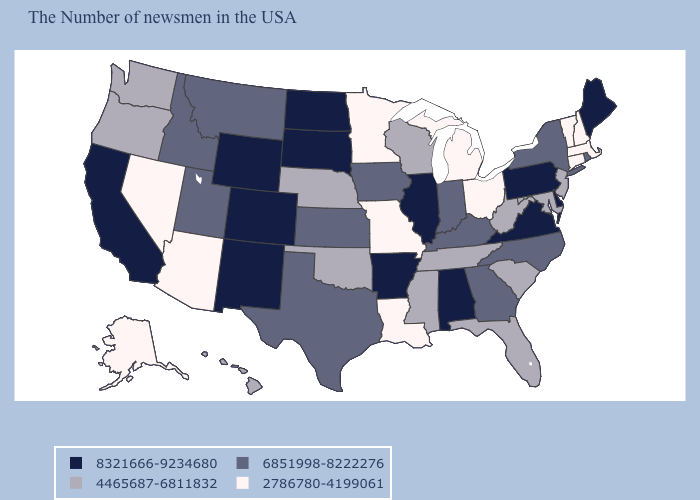Among the states that border Illinois , does Indiana have the highest value?
Keep it brief. Yes. Does North Carolina have the same value as Rhode Island?
Quick response, please. Yes. Name the states that have a value in the range 4465687-6811832?
Keep it brief. New Jersey, Maryland, South Carolina, West Virginia, Florida, Tennessee, Wisconsin, Mississippi, Nebraska, Oklahoma, Washington, Oregon, Hawaii. Name the states that have a value in the range 8321666-9234680?
Keep it brief. Maine, Delaware, Pennsylvania, Virginia, Alabama, Illinois, Arkansas, South Dakota, North Dakota, Wyoming, Colorado, New Mexico, California. Among the states that border Maryland , which have the lowest value?
Write a very short answer. West Virginia. Is the legend a continuous bar?
Write a very short answer. No. Does the map have missing data?
Keep it brief. No. Name the states that have a value in the range 2786780-4199061?
Be succinct. Massachusetts, New Hampshire, Vermont, Connecticut, Ohio, Michigan, Louisiana, Missouri, Minnesota, Arizona, Nevada, Alaska. Name the states that have a value in the range 4465687-6811832?
Keep it brief. New Jersey, Maryland, South Carolina, West Virginia, Florida, Tennessee, Wisconsin, Mississippi, Nebraska, Oklahoma, Washington, Oregon, Hawaii. What is the value of Washington?
Quick response, please. 4465687-6811832. What is the highest value in states that border New Hampshire?
Short answer required. 8321666-9234680. What is the value of Georgia?
Short answer required. 6851998-8222276. Name the states that have a value in the range 2786780-4199061?
Answer briefly. Massachusetts, New Hampshire, Vermont, Connecticut, Ohio, Michigan, Louisiana, Missouri, Minnesota, Arizona, Nevada, Alaska. Among the states that border Georgia , which have the highest value?
Keep it brief. Alabama. What is the value of North Carolina?
Keep it brief. 6851998-8222276. 